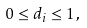Convert formula to latex. <formula><loc_0><loc_0><loc_500><loc_500>0 \leq d _ { i } \leq 1 \, ,</formula> 